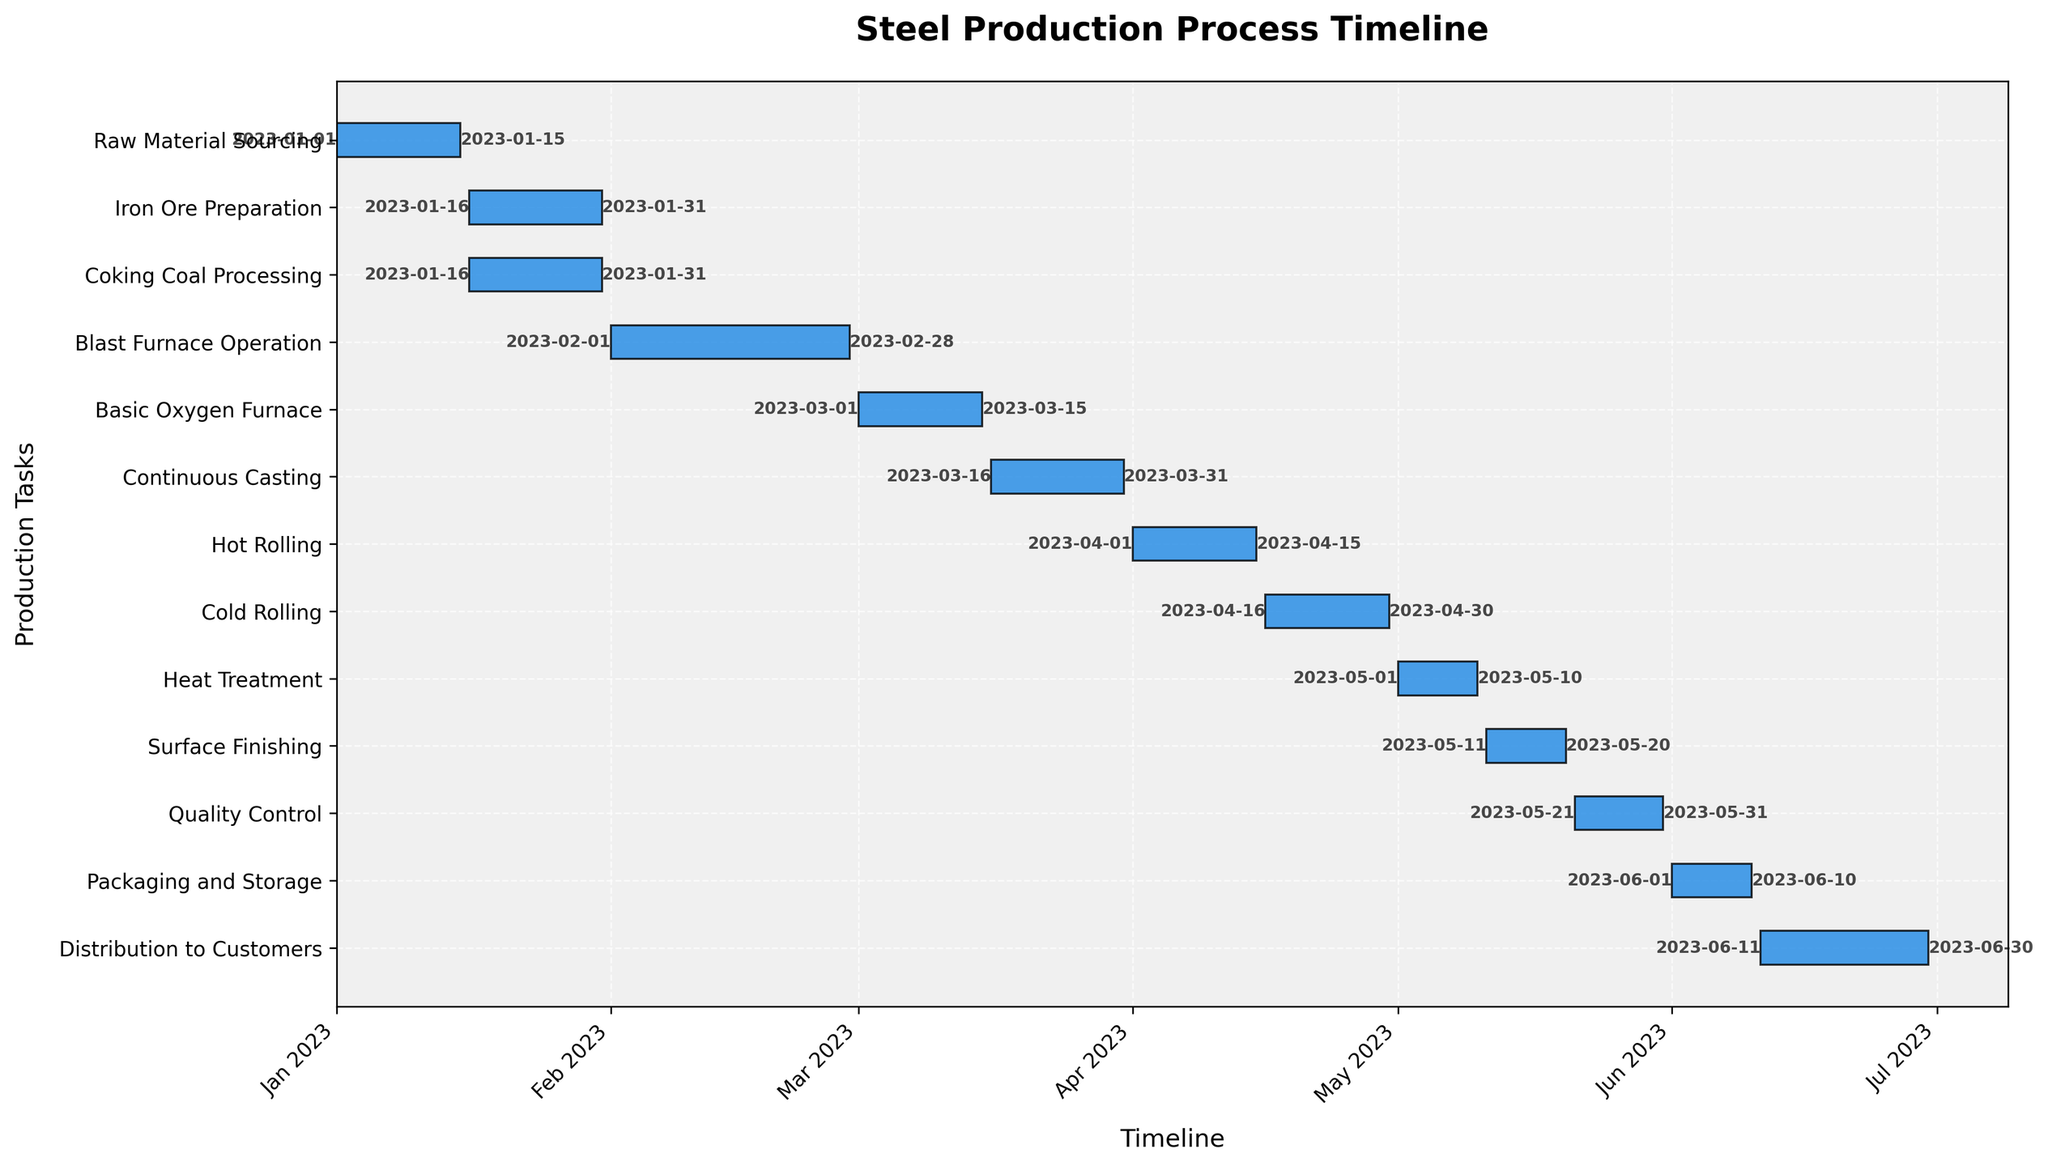What is the title of the chart? The title of the chart is usually found at the top of the figure. In this Gantt chart, it is written in a larger and bolder font compared to other texts. The title of the chart states the overall theme or subject of the figure.
Answer: Steel Production Process Timeline Which task takes the longest duration to complete? In a Gantt chart, the task with the longest bar represents the longest duration. Visually, you need to identify the task with the longest horizontal bar in the figure.
Answer: Distribution to Customers How many tasks are there in the steel production process? To determine the number of tasks, count the number of distinct bars on the y-axis. Each bar represents one task.
Answer: 13 When does the Distribution to Customers task start and end? Check for the Distribution to Customers task on the y-axis. Then, look for the dates labeled at the start and end of its corresponding horizontal bar.
Answer: June 11, 2023 - June 30, 2023 What is the total duration of the steel production process from start to finish? Identify the start date of the first task and the end date of the last task. Then, calculate the difference between these two dates to determine the total duration.
Answer: January 1, 2023, to June 30, 2023, or 6 months Which tasks overlap with the Coking Coal Processing task? Locate the Coking Coal Processing task on the y-axis and note its start and end dates. Then, identify any other tasks with dates that fall within this range.
Answer: Iron Ore Preparation How many tasks are scheduled to occur in March 2023? Identify the tasks whose start or end dates fall within March 2023. Count the number of such tasks.
Answer: Two tasks (Basic Oxygen Furnace and Continuous Casting) Which task is scheduled immediately after the Hot Rolling task? Find the end date of the Hot Rolling task. The task that starts right after this date is the one scheduled immediately after.
Answer: Cold Rolling What is the duration of the Quality Control task? Find the Quality Control task on the y-axis. Calculate the difference between its start date and end date to determine the duration.
Answer: 11 days Which has a shorter duration, Heat Treatment or Surface Finishing? Compare the lengths of the bars for both Heat Treatment and Surface Finishing. The shorter bar represents the task with the shorter duration.
Answer: Surface Finishing 